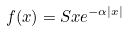<formula> <loc_0><loc_0><loc_500><loc_500>f ( x ) = S x e ^ { - \alpha | x | }</formula> 